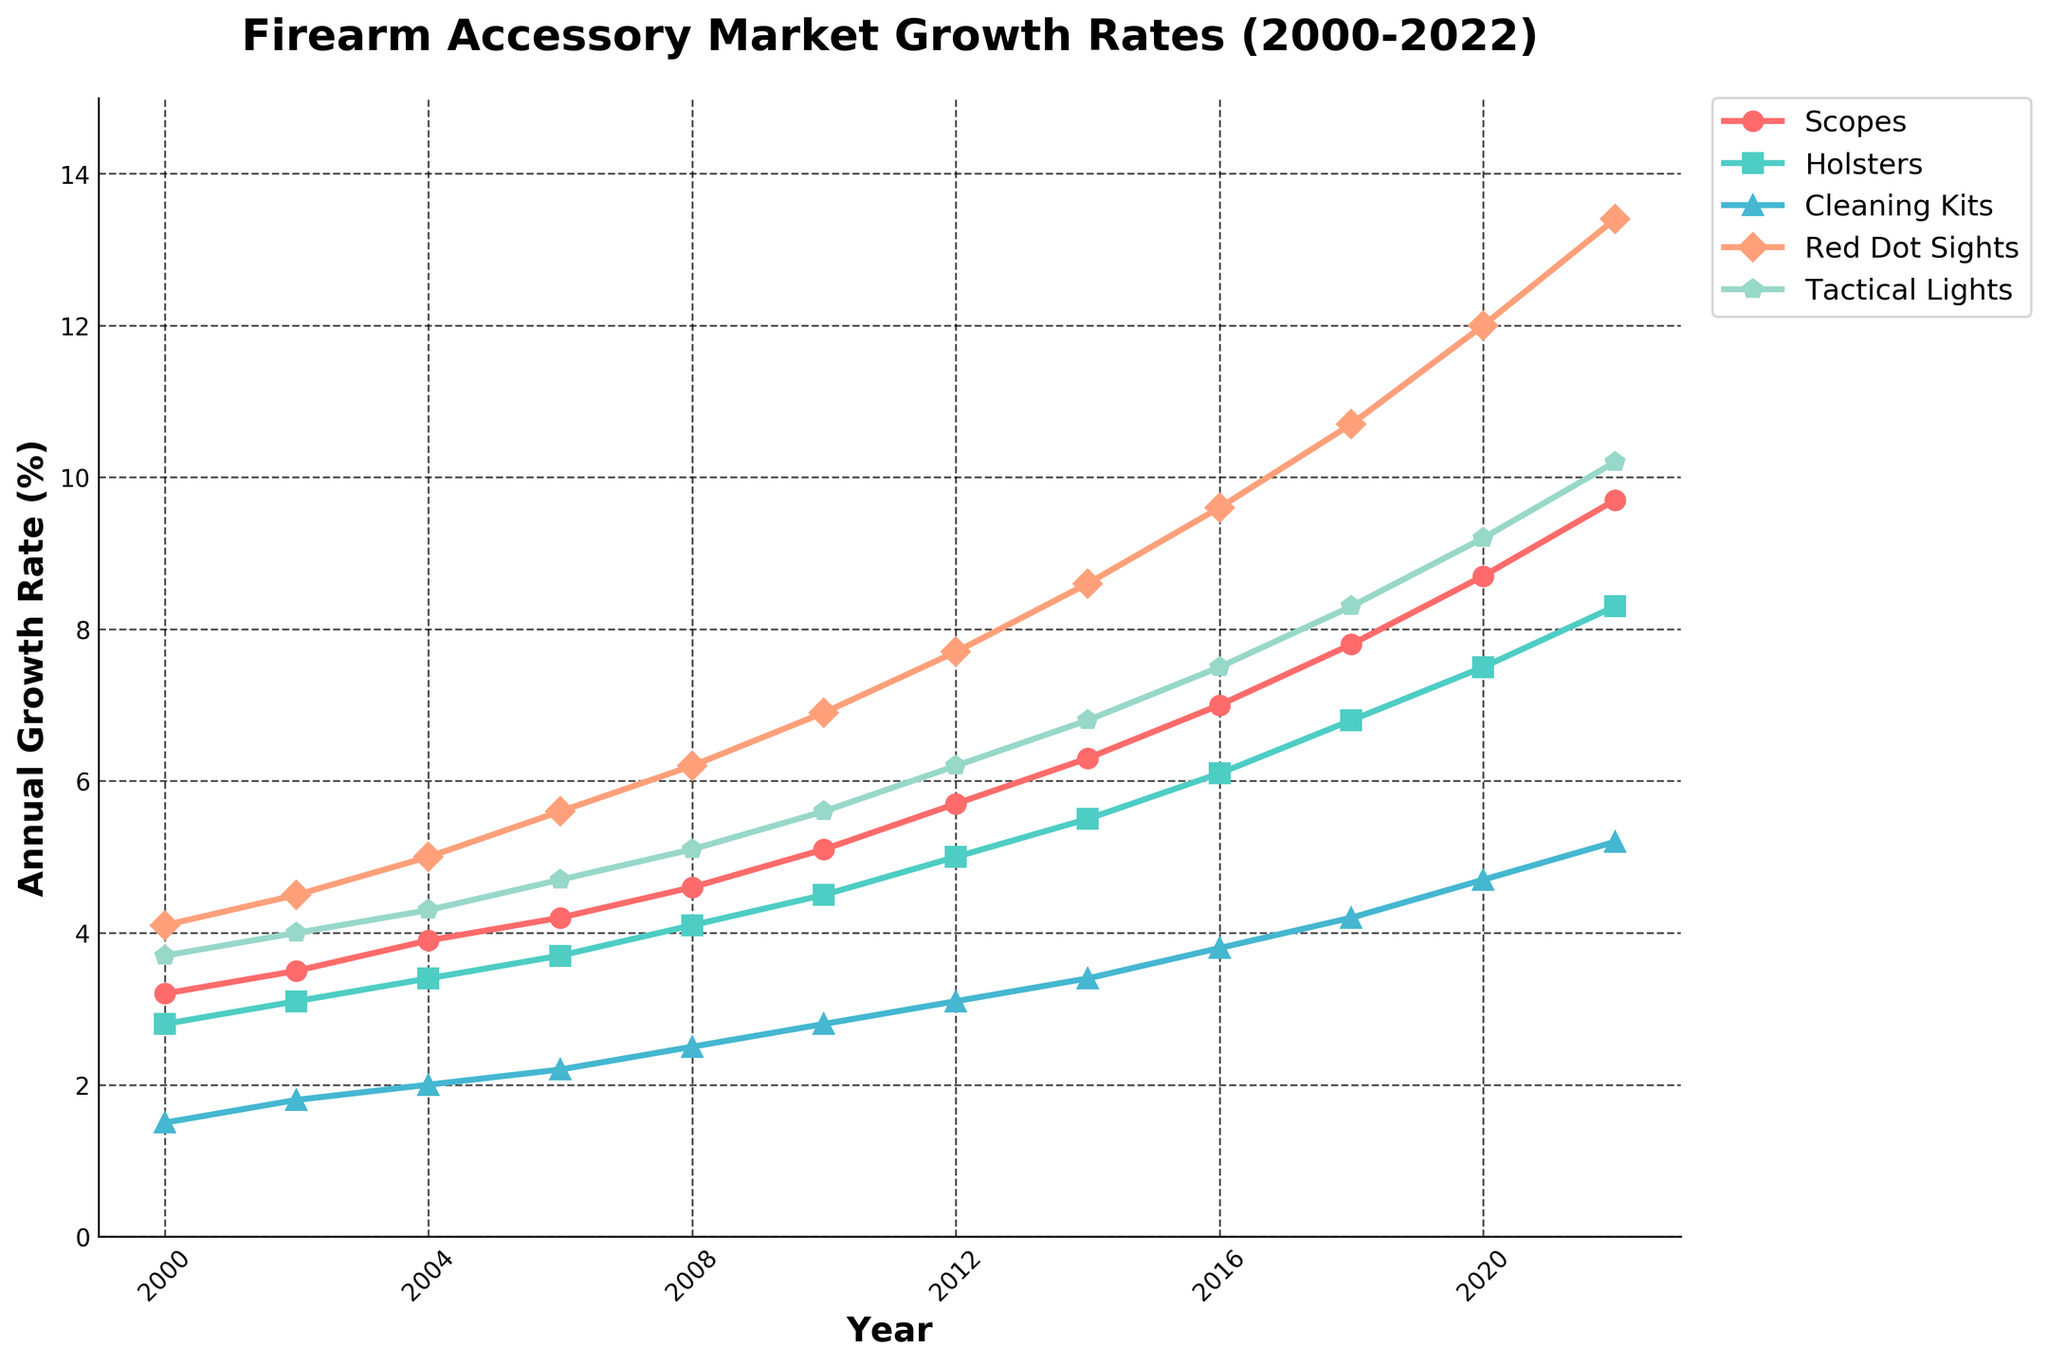Which accessory had the highest annual growth rate in 2022? By examining the plot for the year 2022, we observe that 'Red Dot Sights' has the highest growth rate as it is at the topmost position on the chart.
Answer: Red Dot Sights Between 2008 and 2010, which accessory had the highest increase in growth rate and by how much? Looking at the vertical distance between points from 2008 to 2010 for each accessory, 'Red Dot Sights' shows the largest increase, growing from 6.2% to 6.9%. The increase is computed as 6.9 - 6.2 = 0.7%.
Answer: Red Dot Sights, 0.7% Which accessory has grown steadily without any decline from 2000 to 2022? Observing the entire plot, all five accessories (Scopes, Holsters, Cleaning Kits, Red Dot Sights, Tactical Lights) show a consistent upward trend with no decline at any point.
Answer: All In which year did Tactical Lights first surpass an annual growth rate of 5%? Checking the line that represents 'Tactical Lights', we notice it first crosses the 5% mark in 2008.
Answer: 2008 What is the average annual growth rate for Cleaning Kits from 2000 to 2022? Add up the annual growth rates for Cleaning Kits at all given years and divide by the number of years: (1.5+1.8+2.0+2.2+2.5+2.8+3.1+3.4+3.8+4.2+4.7+5.2)/12 = 38.2/12 = 3.18%.
Answer: 3.18% How does the growth rate of Holsters in 2022 compare to the growth rate of Scopes in 2016? The growth rate of Holsters in 2022 is 8.3%, while the growth rate of Scopes in 2016 is 7.0%. Holsters in 2022 is higher by 8.3 - 7.0 = 1.3%.
Answer: Holsters in 2022 is higher by 1.3% Which year saw a greater increase in Holsters compared to Scopes? Calculating the difference in growth rates for each year, we find that from 2012 to 2014, Holsters increased from 5.0 to 5.5 (0.5%) while Scopes increased from 5.7 to 6.3 (0.6%). The figures indicate a steady increase, but each year's data must be visually compared. Years like 2012 to 2014 and 2014 to 2016 have varying differences that need visual inspection.
Answer: 2012 to 2014, Scopes (slightly higher) Looking at the plot, which accessory consistently ranks second in annual growth rate from 2000 to 2006? By visually inspecting the plot, 'Red Dot Sights' consistently holds the second position in annual growth rate from 2000 to 2006.
Answer: Red Dot Sights What is the combined growth rate for Tactical Lights and Red Dot Sights in 2010? Adding the growth rates from both 'Tactical Lights' and 'Red Dot Sights' in 2010: 5.6 + 6.9 = 12.5%.
Answer: 12.5% 